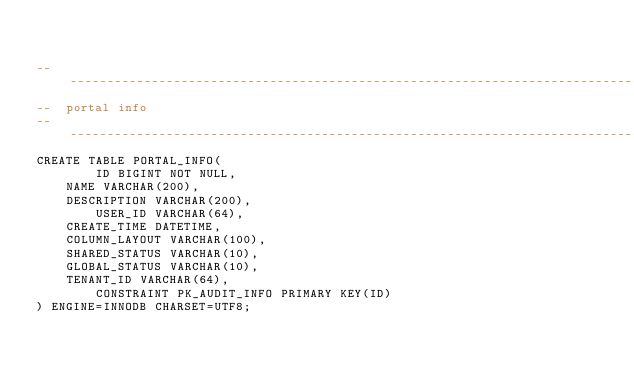<code> <loc_0><loc_0><loc_500><loc_500><_SQL_>

-------------------------------------------------------------------------------
--  portal info
-------------------------------------------------------------------------------
CREATE TABLE PORTAL_INFO(
        ID BIGINT NOT NULL,
	NAME VARCHAR(200),
	DESCRIPTION VARCHAR(200),
        USER_ID VARCHAR(64),
	CREATE_TIME DATETIME,
	COLUMN_LAYOUT VARCHAR(100),
	SHARED_STATUS VARCHAR(10),
	GLOBAL_STATUS VARCHAR(10),
	TENANT_ID VARCHAR(64),
        CONSTRAINT PK_AUDIT_INFO PRIMARY KEY(ID)
) ENGINE=INNODB CHARSET=UTF8;

</code> 